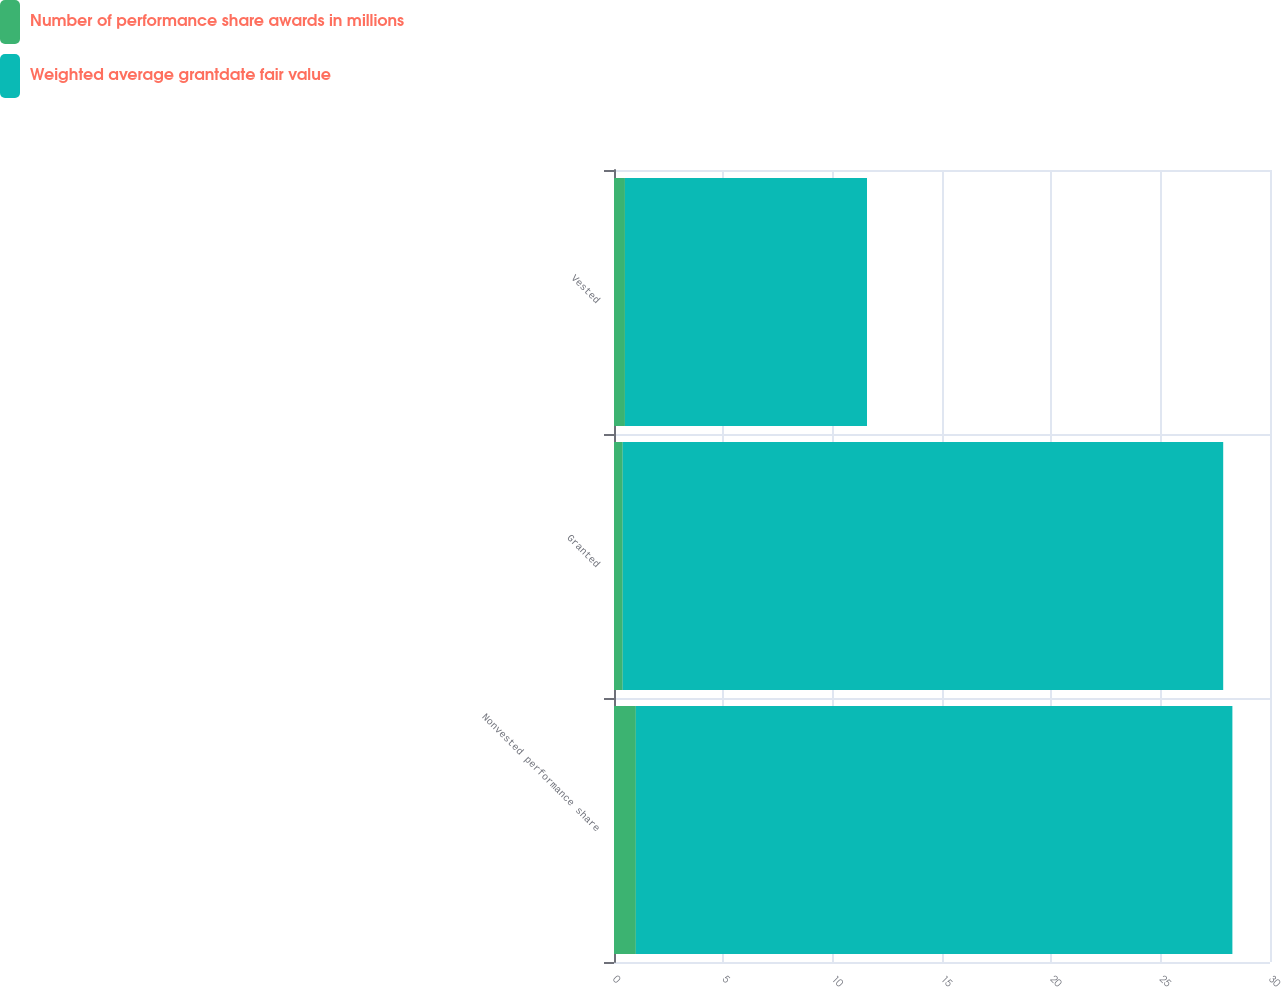Convert chart to OTSL. <chart><loc_0><loc_0><loc_500><loc_500><stacked_bar_chart><ecel><fcel>Nonvested performance share<fcel>Granted<fcel>Vested<nl><fcel>Number of performance share awards in millions<fcel>1<fcel>0.4<fcel>0.5<nl><fcel>Weighted average grantdate fair value<fcel>27.28<fcel>27.46<fcel>11.07<nl></chart> 